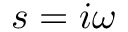Convert formula to latex. <formula><loc_0><loc_0><loc_500><loc_500>s = i \omega</formula> 